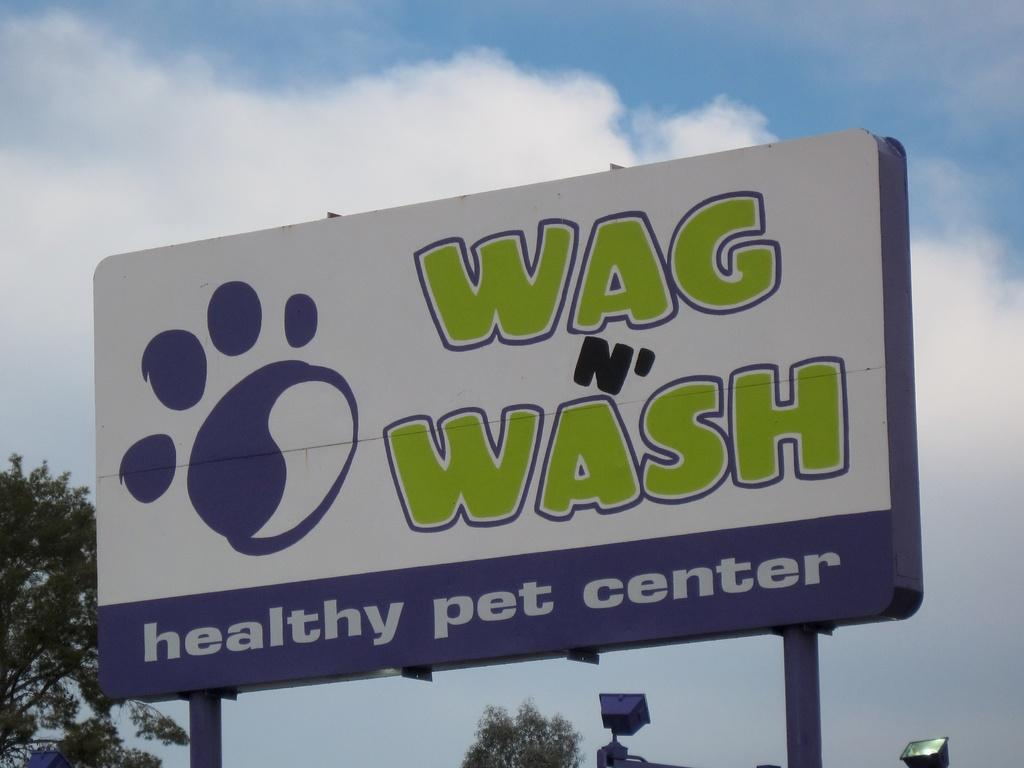What is located in the foreground of the image? There is a board in the foreground of the image. What can be seen in the background of the image? There are trees, lights, and the sky visible in the background of the image. What is the condition of the sky in the image? The sky is visible in the background of the image, and there are clouds present. What type of goose can be seen flying in the image? There is no goose present in the image; it only features a board, trees, lights, and the sky with clouds. Can you describe the tail of the tooth in the image? There is no tooth present in the image, so it is not possible to describe its tail. 